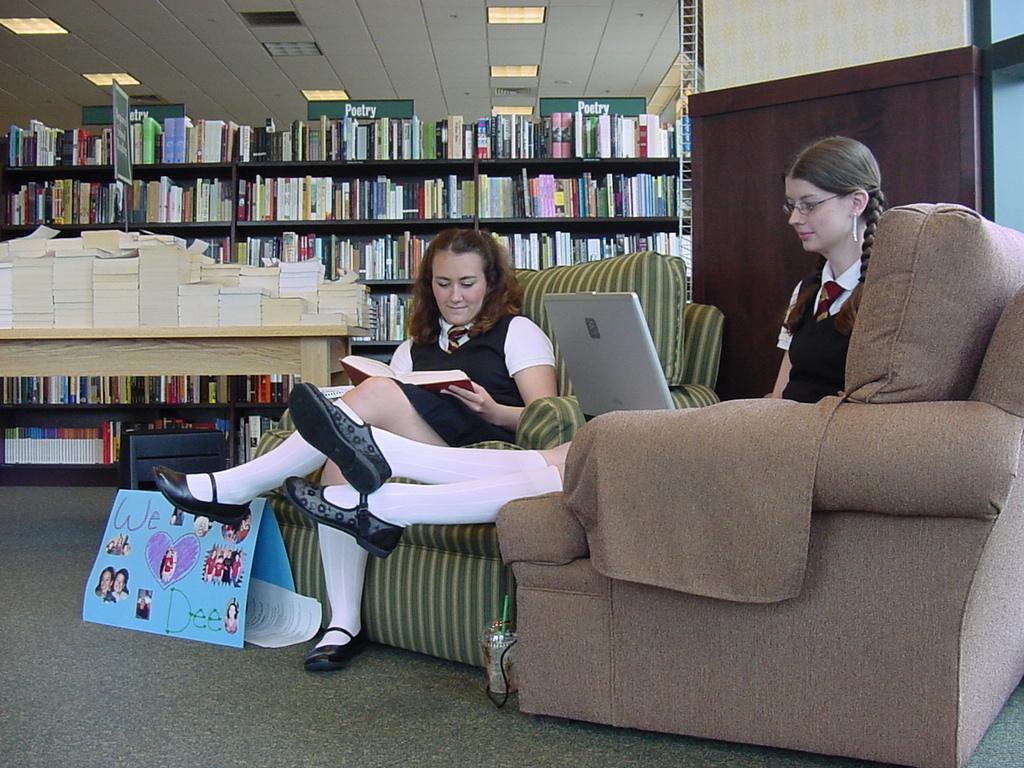Please provide a concise description of this image. In this image we can see women sitting on the couches by holding book and laptop in their hands. In the background we can see books arranged in the cupboards and on the table, electric lights, name boards and papers pasted on the cardboard which is placed on the floor. 